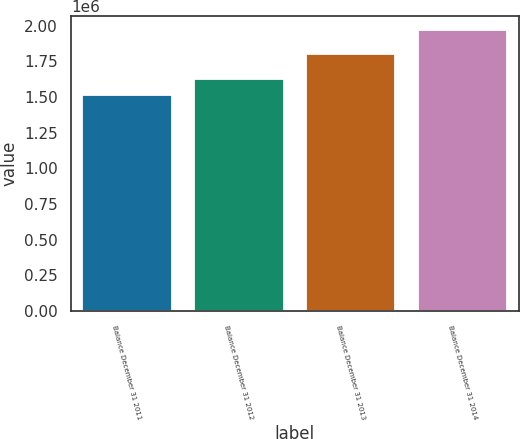Convert chart to OTSL. <chart><loc_0><loc_0><loc_500><loc_500><bar_chart><fcel>Balance December 31 2011<fcel>Balance December 31 2012<fcel>Balance December 31 2013<fcel>Balance December 31 2014<nl><fcel>1.51074e+06<fcel>1.62424e+06<fcel>1.8044e+06<fcel>1.96872e+06<nl></chart> 